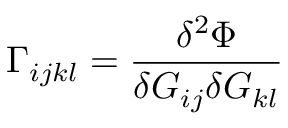<formula> <loc_0><loc_0><loc_500><loc_500>\Gamma _ { i j k l } = { \frac { \delta ^ { 2 } \Phi } { \delta G _ { i j } \delta G _ { k l } } }</formula> 